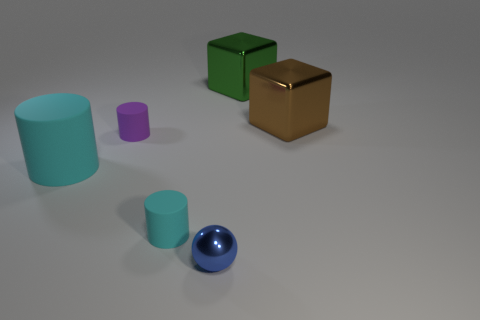Add 2 large rubber cylinders. How many objects exist? 8 Subtract all cubes. How many objects are left? 4 Subtract 0 green cylinders. How many objects are left? 6 Subtract all small gray matte balls. Subtract all large green metal blocks. How many objects are left? 5 Add 1 tiny cyan matte cylinders. How many tiny cyan matte cylinders are left? 2 Add 4 yellow matte things. How many yellow matte things exist? 4 